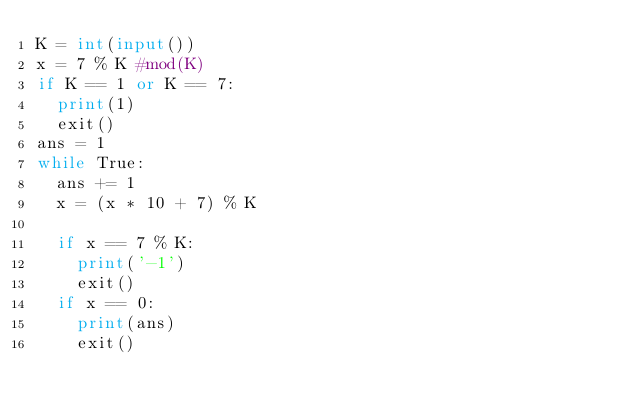<code> <loc_0><loc_0><loc_500><loc_500><_Python_>K = int(input())
x = 7 % K #mod(K)
if K == 1 or K == 7:
  print(1)
  exit()
ans = 1
while True:
  ans += 1
  x = (x * 10 + 7) % K
  
  if x == 7 % K:
    print('-1')
    exit()
  if x == 0:
    print(ans)
    exit()</code> 